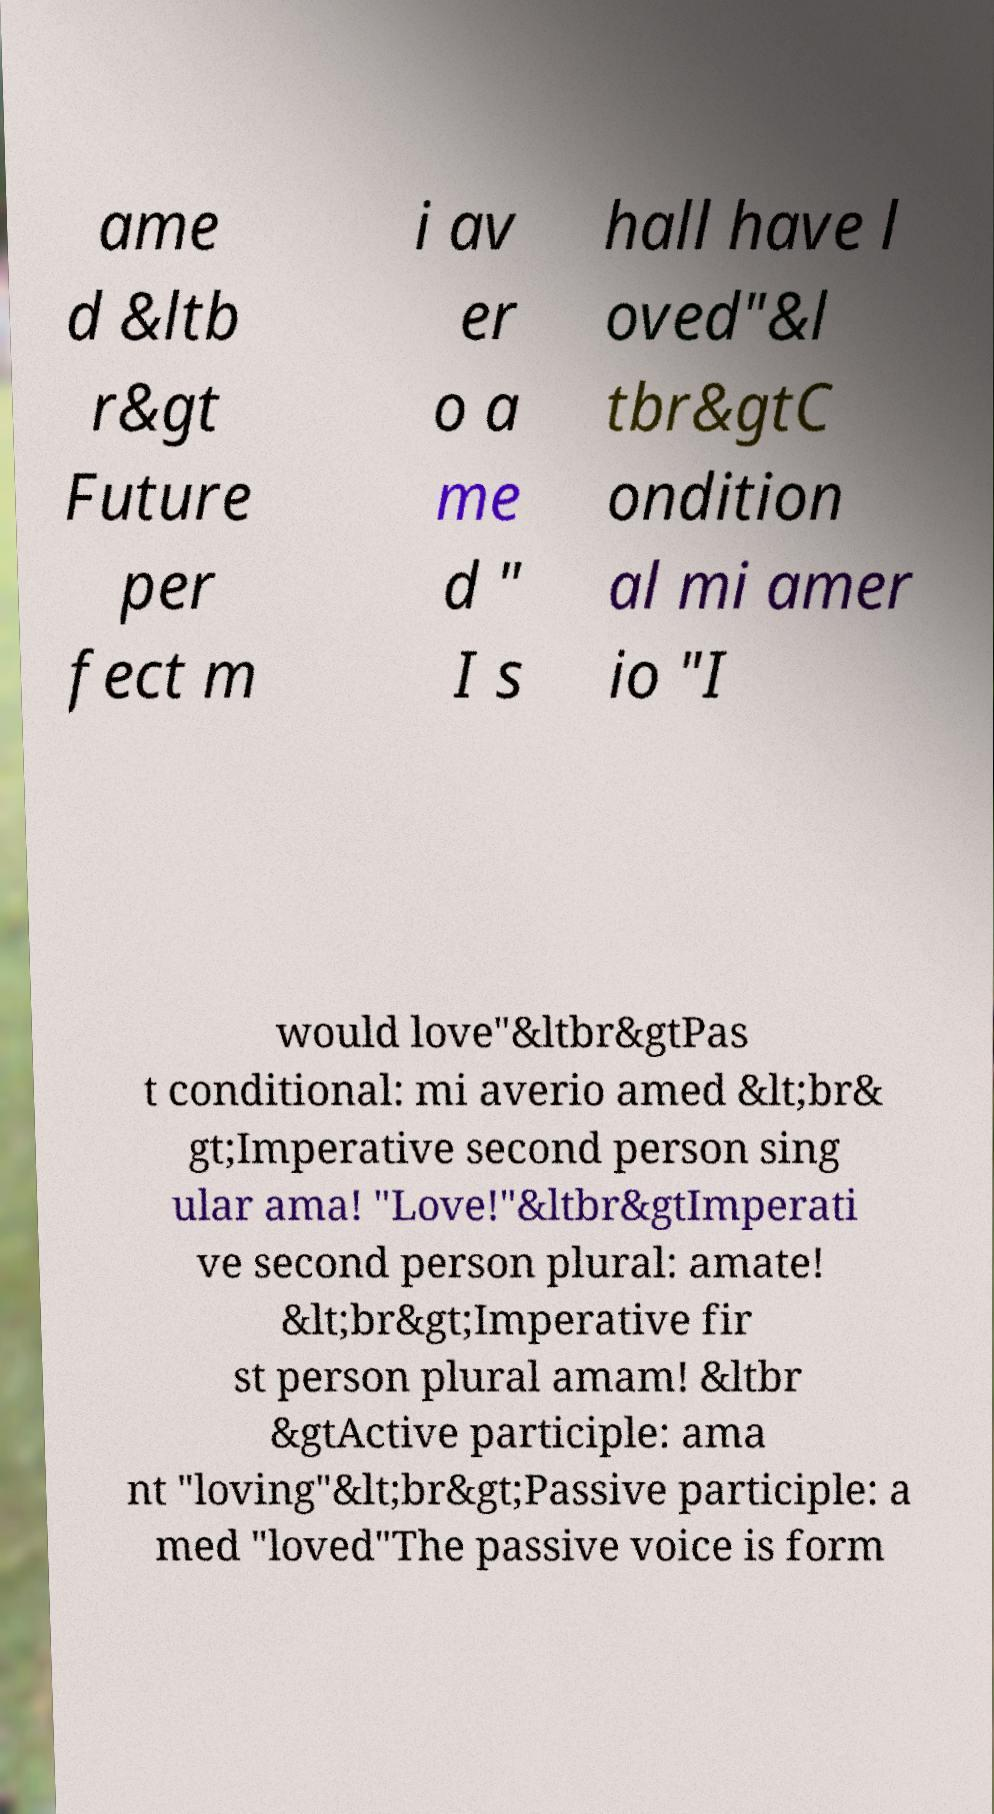Could you extract and type out the text from this image? ame d &ltb r&gt Future per fect m i av er o a me d " I s hall have l oved"&l tbr&gtC ondition al mi amer io "I would love"&ltbr&gtPas t conditional: mi averio amed &lt;br& gt;Imperative second person sing ular ama! "Love!"&ltbr&gtImperati ve second person plural: amate! &lt;br&gt;Imperative fir st person plural amam! &ltbr &gtActive participle: ama nt "loving"&lt;br&gt;Passive participle: a med "loved"The passive voice is form 